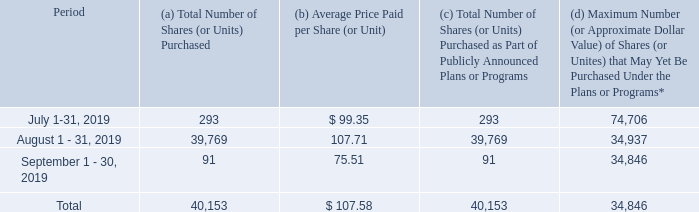REPURCHASE OF COMPANY SHARES
The Company repurchased a total of 75,113 and 74,880 shares of its common stock during fiscal 2019 and fiscal 2018, respectively, for cash totaling approximately $7.5 million and $7.7 million, respectively. All repurchased shares were recorded in treasury stock at cost. At September 2019, 34,846 shares of the Company’s common shares remained authorized for repurchase in either the open market or privately negotiated transactions, as previously approved by the Company’s Board of Directors. In October 2019, our Board of Directors renewed the repurchase authorization for up to 75,000 shares of the Company’s common stock.
During the fourth quarter of fiscal 2019, the Company repurchased shares of its common stock for cash totaling approximately $4.3 million. The following table summarizes these repurchases made by or on behalf of our Company or certain affiliated purchasers of shares of our common stock for the quarterly period ended September 30, 2019:
* In October 2019 and subsequent to the end of fiscal 2019, our Board of Directors authorized purchases of up to
75,000 shares of our Company’s common stock in open market or negotiated transactions. Management was
given discretion to determine the number and pricing of the shares to be purchased, as well as the timing of any
such purchases.
How many shares of its common stock did the company repurchase in fiscal 2019 and fiscal 2018, respectively? 75,113, 74,880. How much did the company pay to repurchase shares of its common stock during fiscal 2019 and fiscal 2018, respectively? $7.5 million, $7.7 million. What is the total number of shares purchased by the company in August and September 2019 respectively? 39,769, 91. What is the percentage change in the shares of common stock repurchased between fiscal 2018 and 2019?
Answer scale should be: percent. (75,113 - 74,880)/74,880 
Answer: 0.31. What is the percentage change in the amount paid by the company to purchase its common stock during 2018 and 2019?
Answer scale should be: percent. (7.5 - 7.7)/7.7 
Answer: -2.6. What is the percentage change in the number of shares (or units) purchased by the company between August and September 2019?
Answer scale should be: percent. (91 - 39,769)/39,769 
Answer: -99.77. 